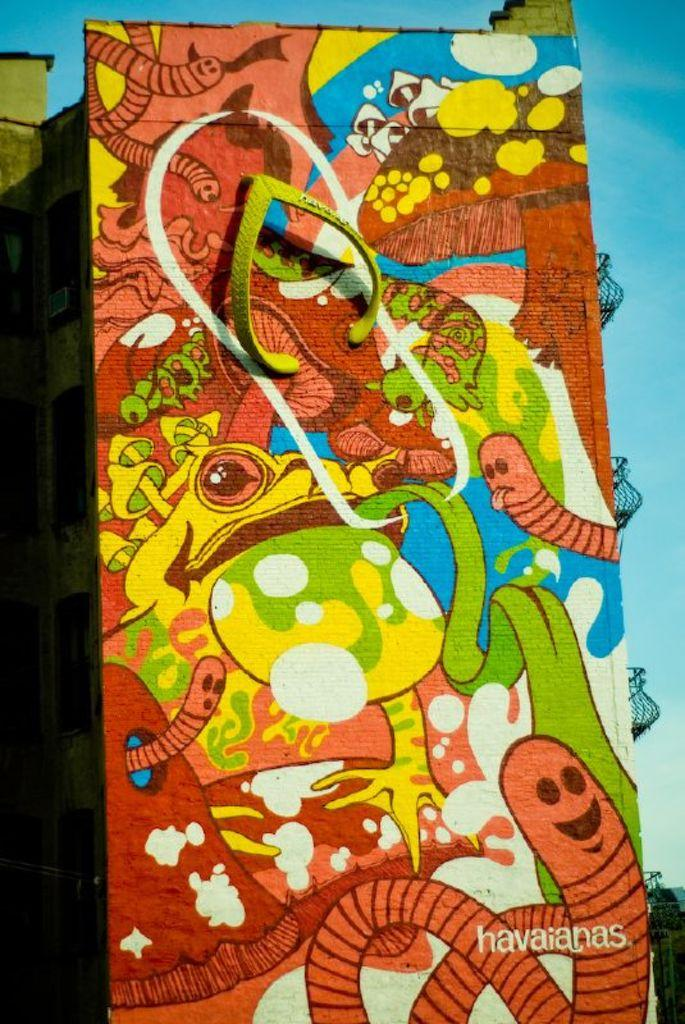<image>
Write a terse but informative summary of the picture. a frog next to other animals that say havainas 